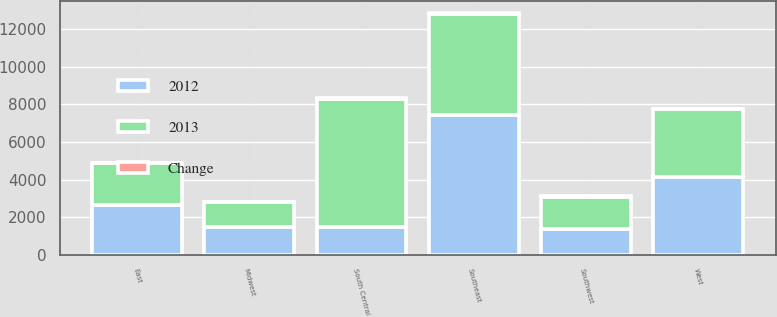<chart> <loc_0><loc_0><loc_500><loc_500><stacked_bar_chart><ecel><fcel>East<fcel>Midwest<fcel>Southeast<fcel>South Central<fcel>Southwest<fcel>West<nl><fcel>2012<fcel>2624<fcel>1480<fcel>7408<fcel>1480<fcel>1381<fcel>4153<nl><fcel>2013<fcel>2244<fcel>1301<fcel>5378<fcel>6822<fcel>1715<fcel>3588<nl><fcel>Change<fcel>17<fcel>14<fcel>38<fcel>18<fcel>19<fcel>16<nl></chart> 